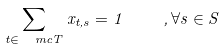Convert formula to latex. <formula><loc_0><loc_0><loc_500><loc_500>\sum _ { t \in \ m c T } x _ { t , s } = 1 \quad , \forall s \in S</formula> 